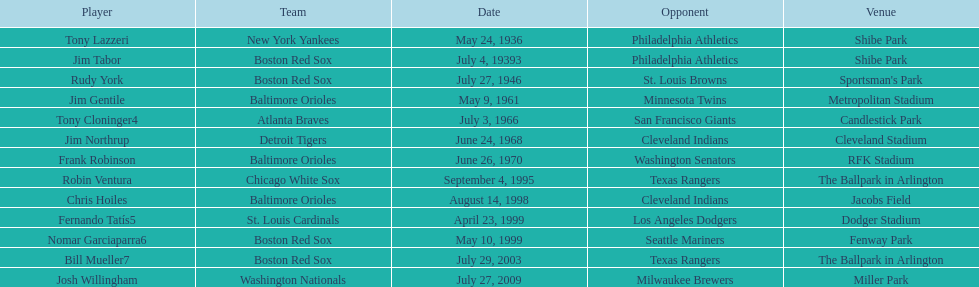Give me the full table as a dictionary. {'header': ['Player', 'Team', 'Date', 'Opponent', 'Venue'], 'rows': [['Tony Lazzeri', 'New York Yankees', 'May 24, 1936', 'Philadelphia Athletics', 'Shibe Park'], ['Jim Tabor', 'Boston Red Sox', 'July 4, 19393', 'Philadelphia Athletics', 'Shibe Park'], ['Rudy York', 'Boston Red Sox', 'July 27, 1946', 'St. Louis Browns', "Sportsman's Park"], ['Jim Gentile', 'Baltimore Orioles', 'May 9, 1961', 'Minnesota Twins', 'Metropolitan Stadium'], ['Tony Cloninger4', 'Atlanta Braves', 'July 3, 1966', 'San Francisco Giants', 'Candlestick Park'], ['Jim Northrup', 'Detroit Tigers', 'June 24, 1968', 'Cleveland Indians', 'Cleveland Stadium'], ['Frank Robinson', 'Baltimore Orioles', 'June 26, 1970', 'Washington Senators', 'RFK Stadium'], ['Robin Ventura', 'Chicago White Sox', 'September 4, 1995', 'Texas Rangers', 'The Ballpark in Arlington'], ['Chris Hoiles', 'Baltimore Orioles', 'August 14, 1998', 'Cleveland Indians', 'Jacobs Field'], ['Fernando Tatís5', 'St. Louis Cardinals', 'April 23, 1999', 'Los Angeles Dodgers', 'Dodger Stadium'], ['Nomar Garciaparra6', 'Boston Red Sox', 'May 10, 1999', 'Seattle Mariners', 'Fenway Park'], ['Bill Mueller7', 'Boston Red Sox', 'July 29, 2003', 'Texas Rangers', 'The Ballpark in Arlington'], ['Josh Willingham', 'Washington Nationals', 'July 27, 2009', 'Milwaukee Brewers', 'Miller Park']]} What was the name of the last person to accomplish this up to date? Josh Willingham. 